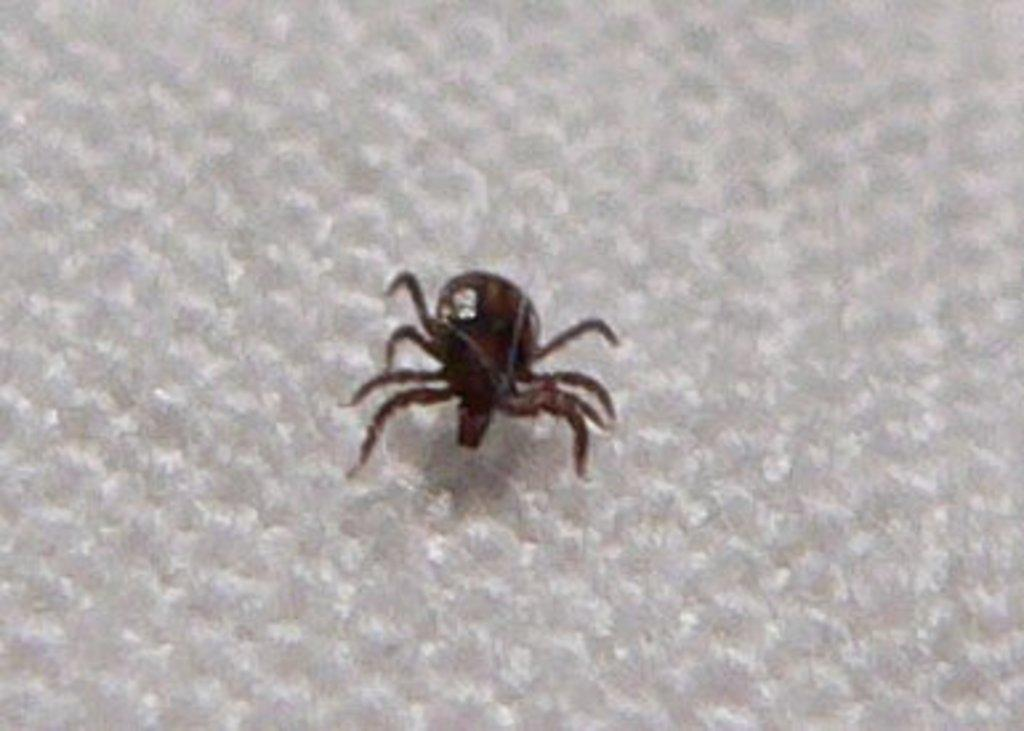What type of creature can be seen in the image? There is an insect in the image. What is the color of the insect? The insect is brown in color. What is the background of the image? The insect is on a white surface. What type of cakes are being served in the image? There are no cakes present in the image; it features an insect on a white surface. How does the pie look like in the image? There is no pie present in the image. 